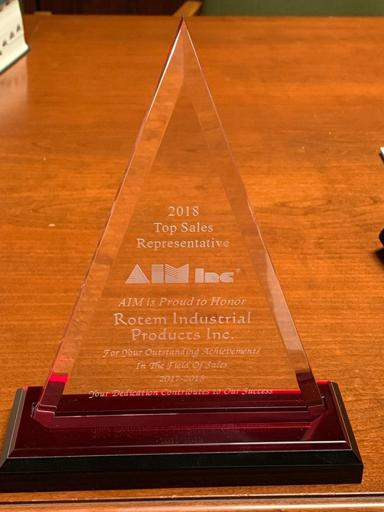What was the achievement of Rotem Industrial Products Inc. in 2018? In 2018, Rotem Industrial Products Inc. achieved significant recognition and was honored with the 'Top Sales Representative' award by AIM, reflecting their excellence in sales performance and commitment to their field. 